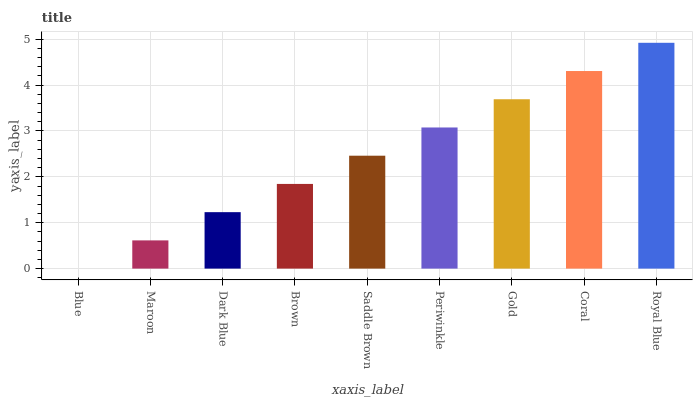Is Blue the minimum?
Answer yes or no. Yes. Is Royal Blue the maximum?
Answer yes or no. Yes. Is Maroon the minimum?
Answer yes or no. No. Is Maroon the maximum?
Answer yes or no. No. Is Maroon greater than Blue?
Answer yes or no. Yes. Is Blue less than Maroon?
Answer yes or no. Yes. Is Blue greater than Maroon?
Answer yes or no. No. Is Maroon less than Blue?
Answer yes or no. No. Is Saddle Brown the high median?
Answer yes or no. Yes. Is Saddle Brown the low median?
Answer yes or no. Yes. Is Blue the high median?
Answer yes or no. No. Is Periwinkle the low median?
Answer yes or no. No. 